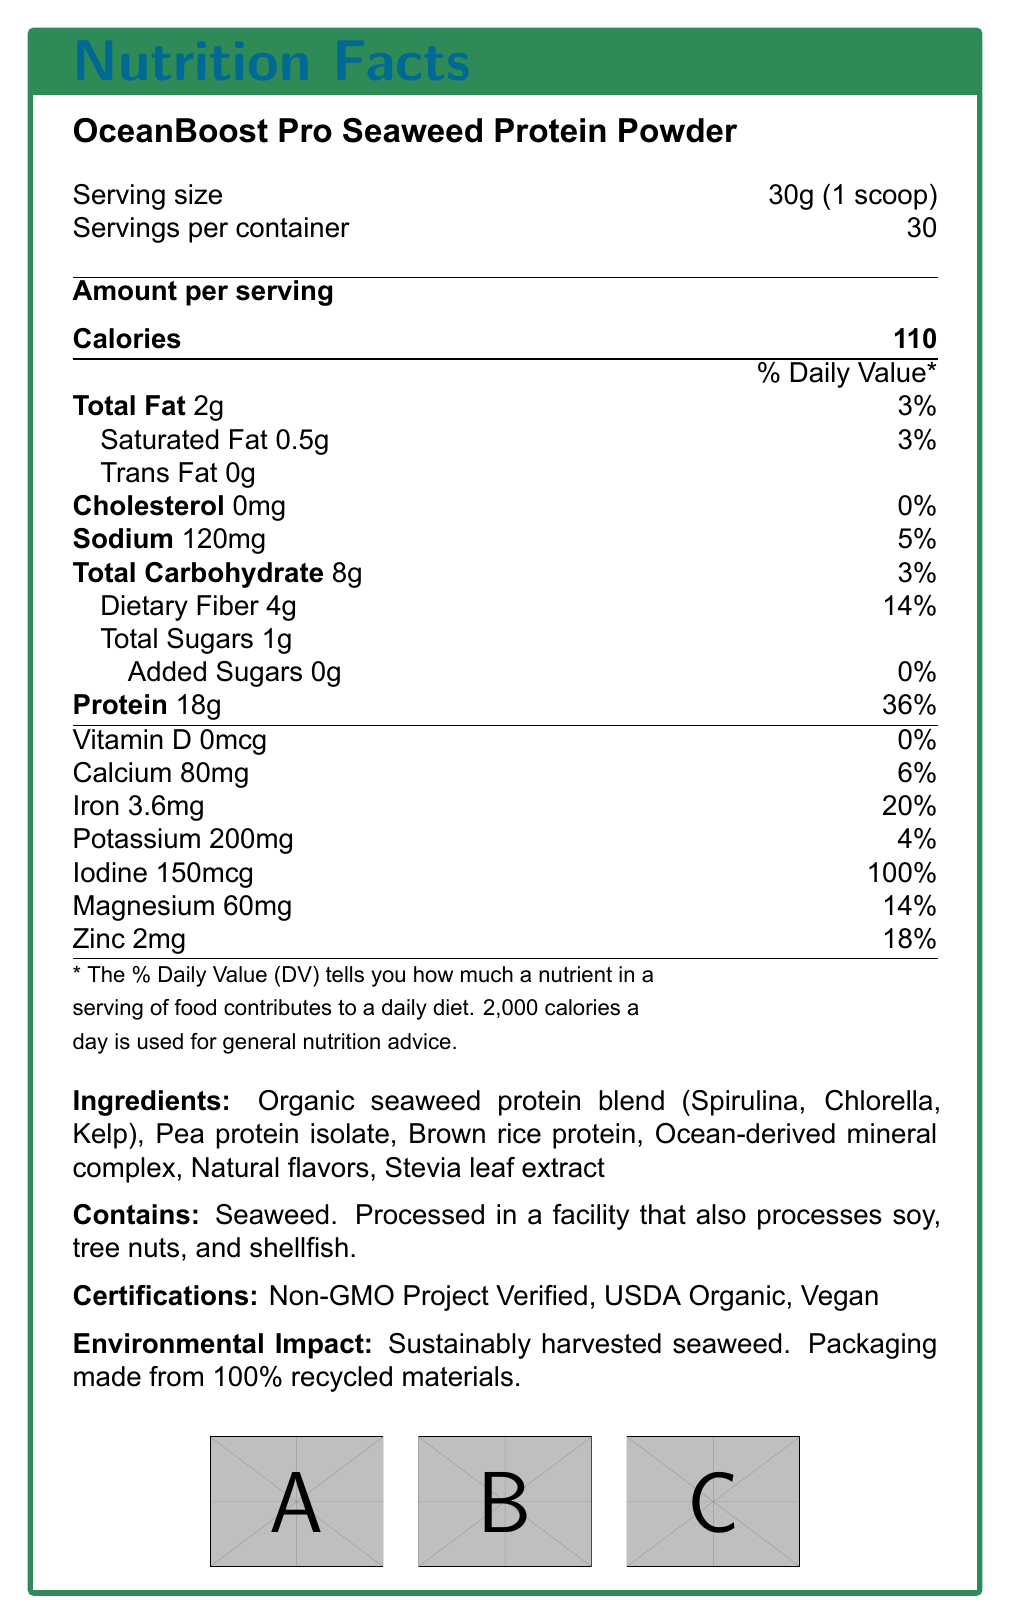what is the serving size of OceanBoost Pro Seaweed Protein Powder? The serving size is explicitly mentioned as "30g (1 scoop)" in the top section of the document.
Answer: 30g (1 scoop) how many servings are in one container? The number of servings per container is listed as "30" right below the serving size.
Answer: 30 how many calories are in one serving? The calorie count per serving is highlighted prominently as "Calories 110" in the "Amount per serving" section.
Answer: 110 what is the total fat content per serving? The document states "Total Fat 2g" under the "Amount per serving" section.
Answer: 2g how much protein is in one serving? The document lists "Protein 18g" under the "Amount per serving" section.
Answer: 18g what percentage of the daily value of dietary fiber does one serving provide? The document states "Dietary Fiber 4g" and "14%" next to it under the "Total Carbohydrate" section.
Answer: 14% which ingredient in the product is an added sugar? A. Stevia leaf extract B. Brown rice protein C. Natural flavors D. None The document states that "Added Sugars" are "0g", meaning there are no added sugars in the product.
Answer: D. None how much iodine does one serving contain? A. 60mg B. 150mcg C. 100% D. 0mg The document states "Iodine 150mcg" in the list of vitamins and minerals, and its Daily Value percentage is given as 100%.
Answer: B. 150mcg is the product certified by the USDA? The document lists "USDA Organic" under the "Certifications" section, indicating that the product is certified by the USDA.
Answer: Yes can someone allergic to tree nuts consume this product without concern? The allergen information specifies that the product is "Processed in a facility that also processes soy, tree nuts, and shellfish", which poses a risk for individuals allergic to tree nuts.
Answer: No describe the main idea of this document. The document’s main idea is to provide consumers with comprehensive nutritional information about OceanBoost Pro Seaweed Protein Powder, including its health benefits and certifications.
Answer: The document is a nutrition facts label for OceanBoost Pro Seaweed Protein Powder. It details the nutritional content per serving, including calories, fats, carbohydrates, proteins, and various vitamins and minerals. The label also lists the ingredients, allergen information, certifications, and the product’s environmental impact. what is the main source of protein in this product? The main source of protein is listed as "Organic seaweed protein blend (Spirulina, Chlorella, Kelp)" in the ingredients section.
Answer: Organic seaweed protein blend (Spirulina, Chlorella, Kelp) how much sodium is in one serving and what percentage of the daily value does it represent? The document lists "Sodium 120mg" and its Daily Value as "5%" under the "Amount per serving" section.
Answer: 120mg, 5% is the product suitable for vegans? One of the certifications listed in the document is "Vegan", indicating the product is suitable for vegans.
Answer: Yes which mineral in this product meets 100% of the daily value per serving? The document indicates that "Iodine 150mcg" meets "100%" of the daily value.
Answer: Iodine what is the environmentally friendly aspect of the product's packaging? The document specifies that the packaging is made from "100% recycled materials" under the "Environmental Impact" section.
Answer: Packaging made from 100% recycled materials. where is the seaweed in the product harvested from? The document mentions "Sustainably harvested seaweed" but does not specify the location or source of the seaweed harvesting.
Answer: Cannot be determined 